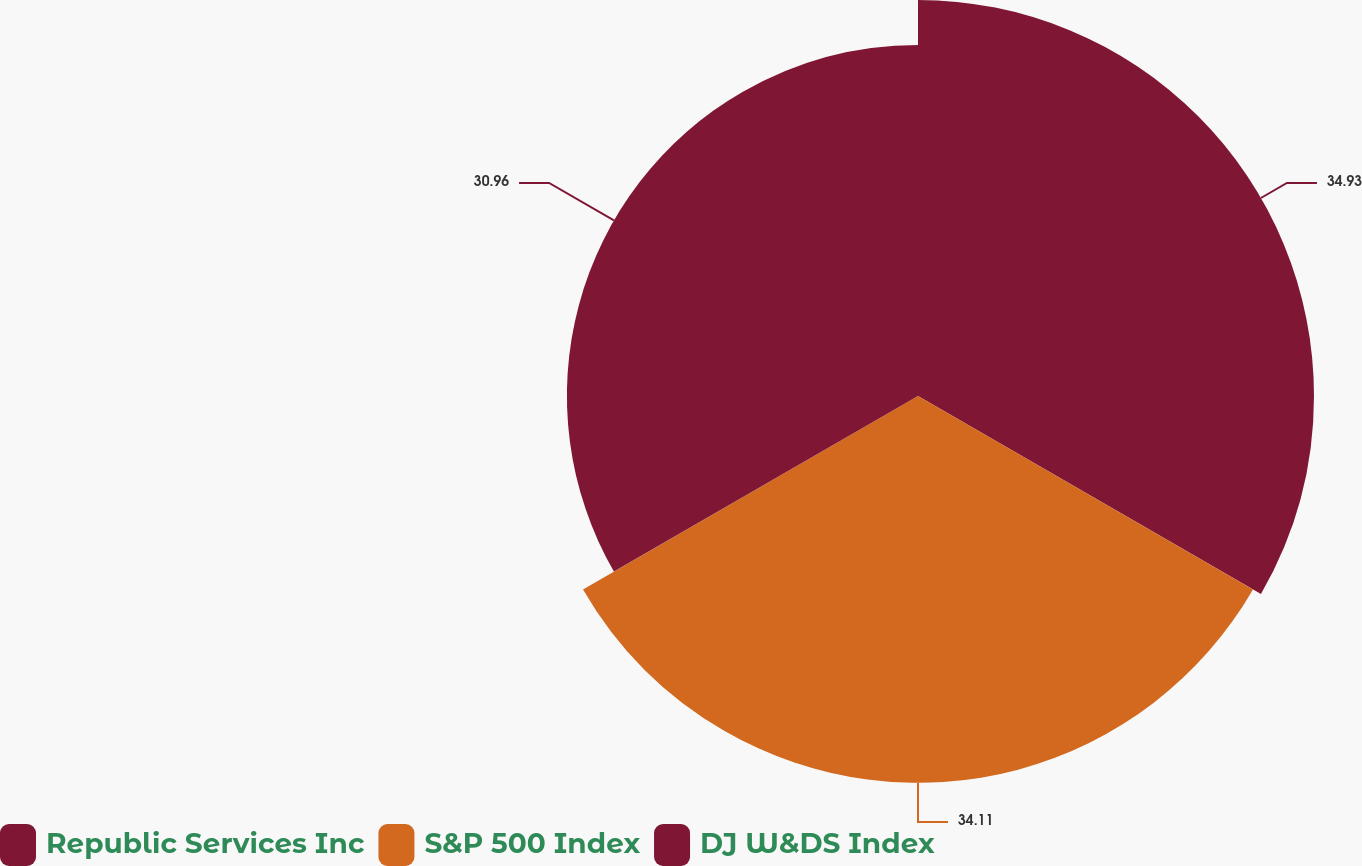<chart> <loc_0><loc_0><loc_500><loc_500><pie_chart><fcel>Republic Services Inc<fcel>S&P 500 Index<fcel>DJ W&DS Index<nl><fcel>34.92%<fcel>34.11%<fcel>30.96%<nl></chart> 